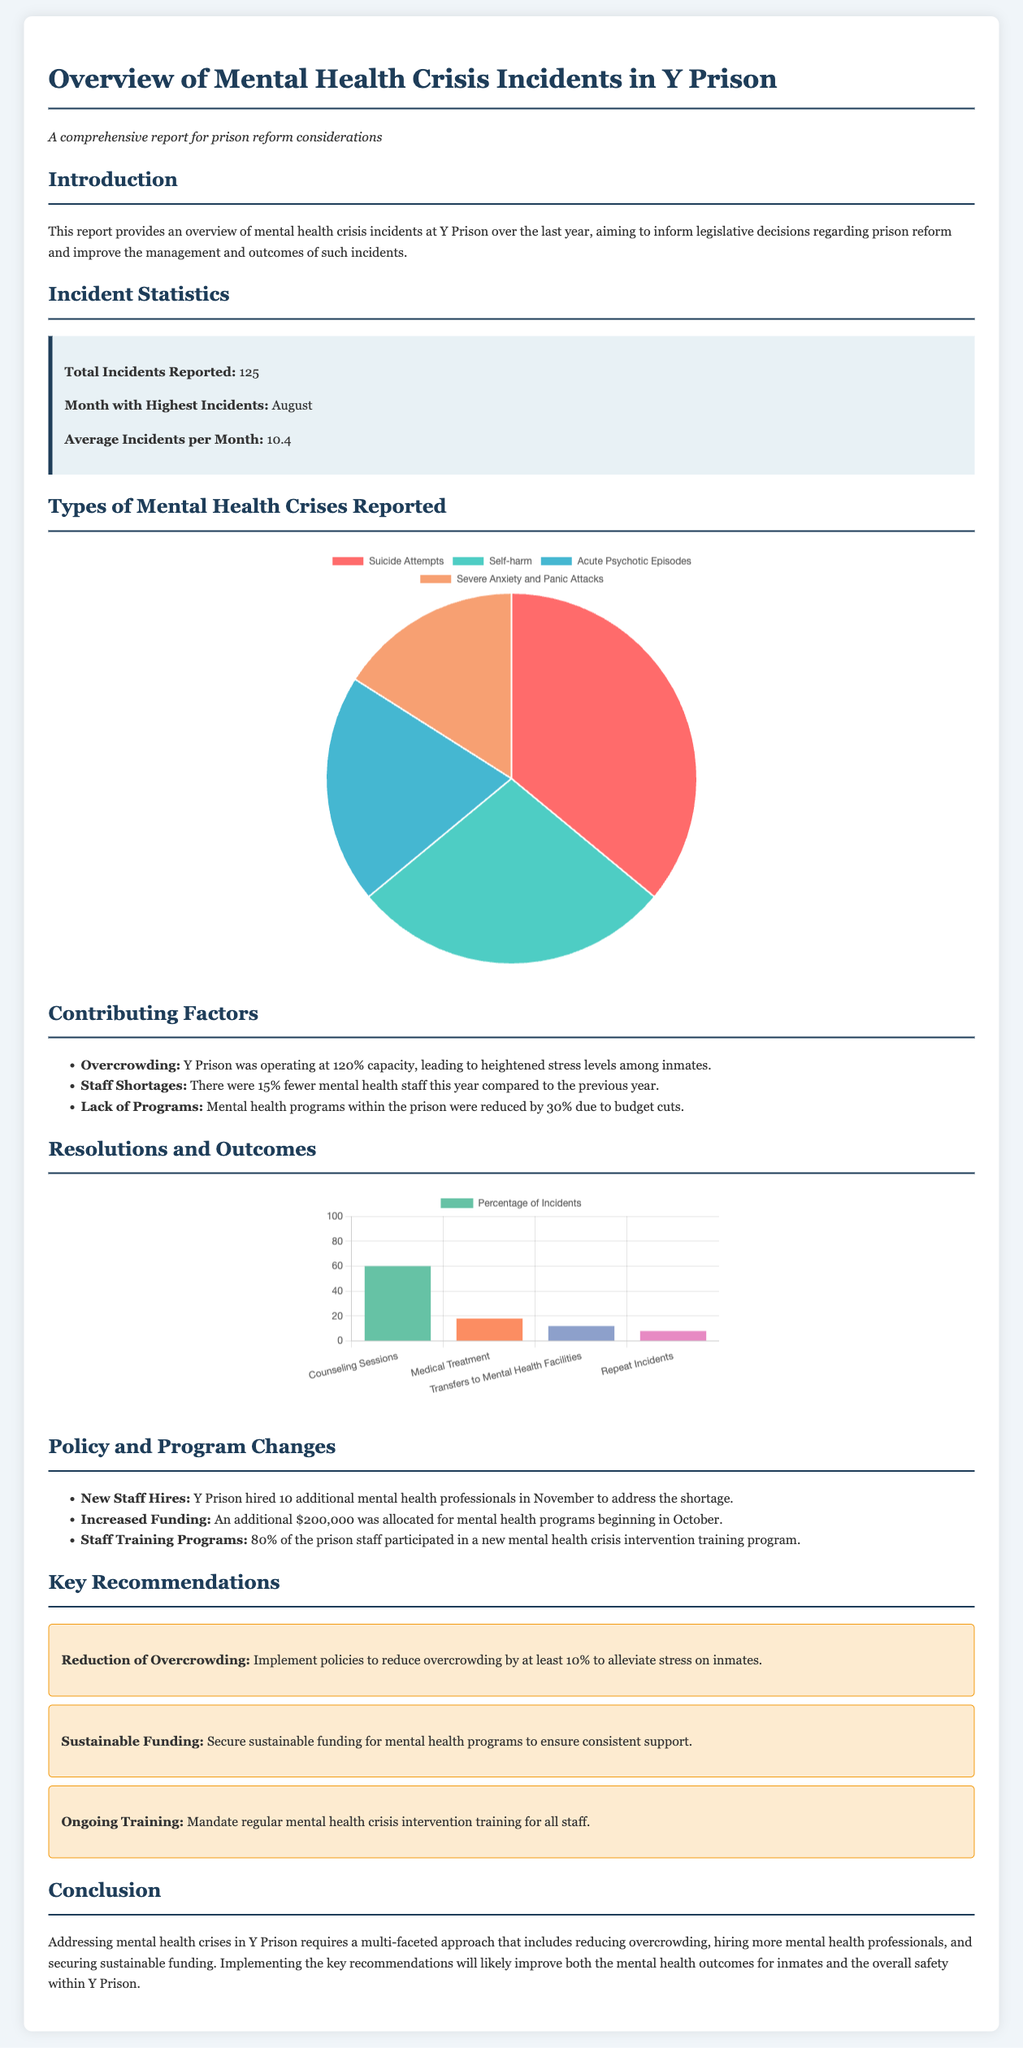what is the total number of incidents reported? The report states that the total number of incidents reported is 125.
Answer: 125 which month had the highest incidents? The report specifies that August was the month with the highest incidents.
Answer: August what percentage of incidents were resolved through counseling sessions? The resolution chart indicates that 60% of incidents were resolved through counseling sessions.
Answer: 60% what was the overcrowding percentage at Y Prison? The document notes that Y Prison was operating at 120% capacity.
Answer: 120% how many additional mental health professionals were hired in November? The report states that Y Prison hired 10 additional mental health professionals.
Answer: 10 what is the amount allocated for increased funding for mental health programs? The document indicates that an additional $200,000 was allocated for mental health programs.
Answer: $200,000 which crisis type had the highest number of incidents? The crisis type chart shows that suicide attempts had the highest number of incidents with 45.
Answer: Suicide Attempts what is one key recommendation from the report? The document lists recommendations such as the reduction of overcrowding.
Answer: Reduction of Overcrowding what percentage of the prison staff participated in the training program? The report mentions that 80% of the prison staff participated in the training program.
Answer: 80% 